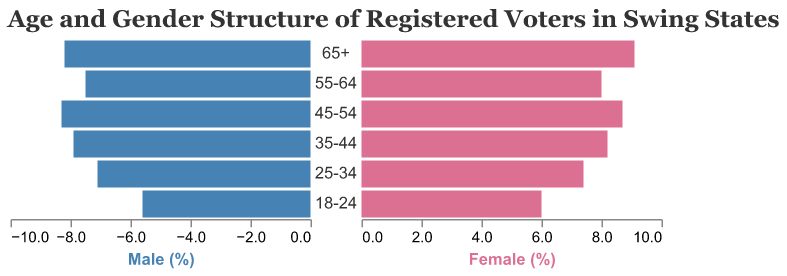What is the title of the figure? The title is prominently indicated at the top of the figure with larger and distinct font settings. It reads: "Age and Gender Structure of Registered Voters in Swing States".
Answer: Age and Gender Structure of Registered Voters in Swing States How many age groups are shown in the figure? By counting the unique age group labels along the vertical axis, we find there are six distinct age groups presented.
Answer: 6 Which age group has the highest percentage of female registered voters? By comparing the bar lengths on the female side, it is observable that the "65+" age group has the longest bar representing females, at 9.1%.
Answer: 65+ What is the percentage difference between male and female registered voters in the "45-54" age group? For this age group, the male percentage is 8.3% and the female percentage is 8.7%. The difference is calculated as 8.7% - 8.3% = 0.4%.
Answer: 0.4% In which age group do males have the lowest percentage of registered voters? By examining the male side of the chart, the shortest bar corresponds to the "18-24" age group, indicating the lowest percentage at 5.6%.
Answer: 18-24 What is the total percentage of registered voters (male and female) in the "55-64" age group? Summing the percentages of male and female voters in this age group: 7.5% (male) + 8.0% (female) = 15.5%.
Answer: 15.5% How do the male and female percentages of registered voters in the "25-34" age group compare? For the "25-34" age group, males are at 7.1% and females are at 7.4%. Females have a slightly higher percentage compared to males by 0.3%.
Answer: Females have a higher percentage by 0.3% Which age group shows almost equal percentages of male and female registered voters? The "35-44" age group has percentages of 7.9% for males and 8.2% for females, which are very close to each other.
Answer: 35-44 What proportion of the total registered voters does the "18-24" age group constitute if the total percentage is 100%? The percentages for the "18-24" age group are 5.6% for males and 6.0% for females. Summing these gives 5.6% + 6.0% = 11.6%, meaning this age group forms 11.6% of the total registered voters.
Answer: 11.6% 